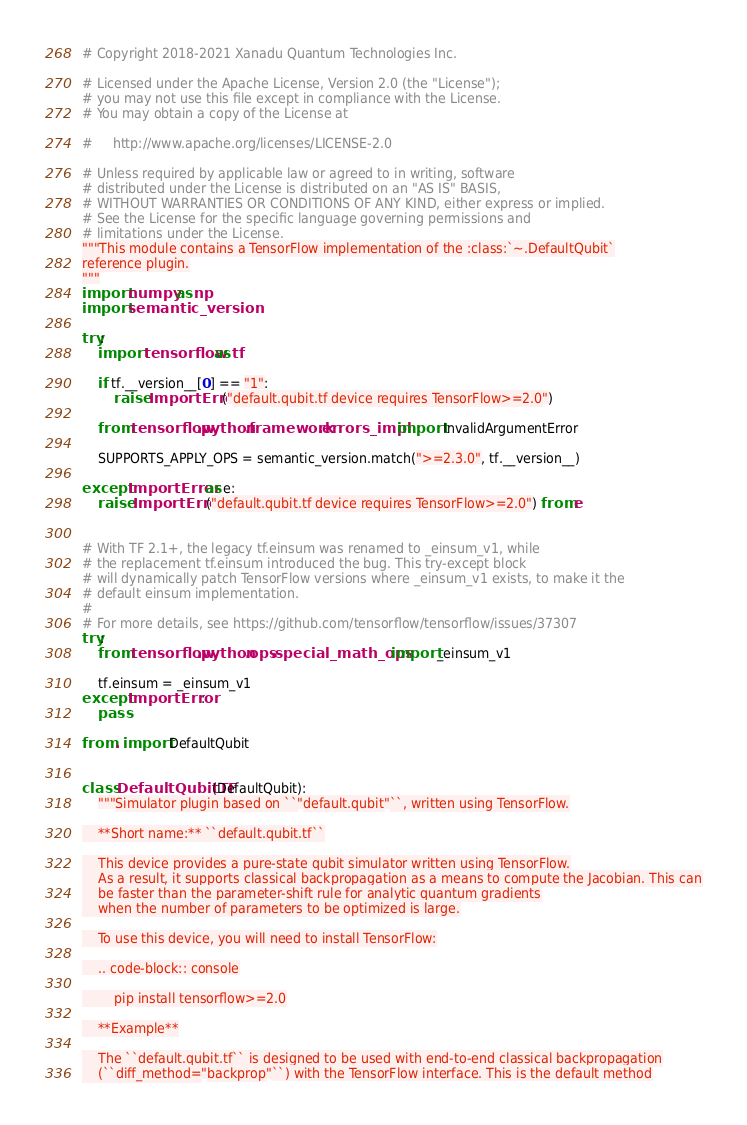Convert code to text. <code><loc_0><loc_0><loc_500><loc_500><_Python_># Copyright 2018-2021 Xanadu Quantum Technologies Inc.

# Licensed under the Apache License, Version 2.0 (the "License");
# you may not use this file except in compliance with the License.
# You may obtain a copy of the License at

#     http://www.apache.org/licenses/LICENSE-2.0

# Unless required by applicable law or agreed to in writing, software
# distributed under the License is distributed on an "AS IS" BASIS,
# WITHOUT WARRANTIES OR CONDITIONS OF ANY KIND, either express or implied.
# See the License for the specific language governing permissions and
# limitations under the License.
"""This module contains a TensorFlow implementation of the :class:`~.DefaultQubit`
reference plugin.
"""
import numpy as np
import semantic_version

try:
    import tensorflow as tf

    if tf.__version__[0] == "1":
        raise ImportError("default.qubit.tf device requires TensorFlow>=2.0")

    from tensorflow.python.framework.errors_impl import InvalidArgumentError

    SUPPORTS_APPLY_OPS = semantic_version.match(">=2.3.0", tf.__version__)

except ImportError as e:
    raise ImportError("default.qubit.tf device requires TensorFlow>=2.0") from e


# With TF 2.1+, the legacy tf.einsum was renamed to _einsum_v1, while
# the replacement tf.einsum introduced the bug. This try-except block
# will dynamically patch TensorFlow versions where _einsum_v1 exists, to make it the
# default einsum implementation.
#
# For more details, see https://github.com/tensorflow/tensorflow/issues/37307
try:
    from tensorflow.python.ops.special_math_ops import _einsum_v1

    tf.einsum = _einsum_v1
except ImportError:
    pass

from . import DefaultQubit


class DefaultQubitTF(DefaultQubit):
    """Simulator plugin based on ``"default.qubit"``, written using TensorFlow.

    **Short name:** ``default.qubit.tf``

    This device provides a pure-state qubit simulator written using TensorFlow.
    As a result, it supports classical backpropagation as a means to compute the Jacobian. This can
    be faster than the parameter-shift rule for analytic quantum gradients
    when the number of parameters to be optimized is large.

    To use this device, you will need to install TensorFlow:

    .. code-block:: console

        pip install tensorflow>=2.0

    **Example**

    The ``default.qubit.tf`` is designed to be used with end-to-end classical backpropagation
    (``diff_method="backprop"``) with the TensorFlow interface. This is the default method</code> 